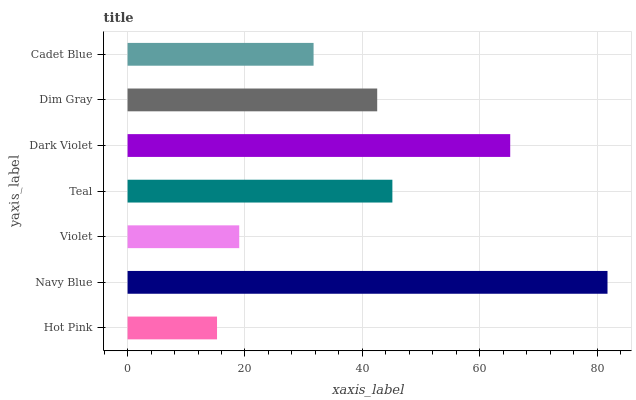Is Hot Pink the minimum?
Answer yes or no. Yes. Is Navy Blue the maximum?
Answer yes or no. Yes. Is Violet the minimum?
Answer yes or no. No. Is Violet the maximum?
Answer yes or no. No. Is Navy Blue greater than Violet?
Answer yes or no. Yes. Is Violet less than Navy Blue?
Answer yes or no. Yes. Is Violet greater than Navy Blue?
Answer yes or no. No. Is Navy Blue less than Violet?
Answer yes or no. No. Is Dim Gray the high median?
Answer yes or no. Yes. Is Dim Gray the low median?
Answer yes or no. Yes. Is Violet the high median?
Answer yes or no. No. Is Dark Violet the low median?
Answer yes or no. No. 